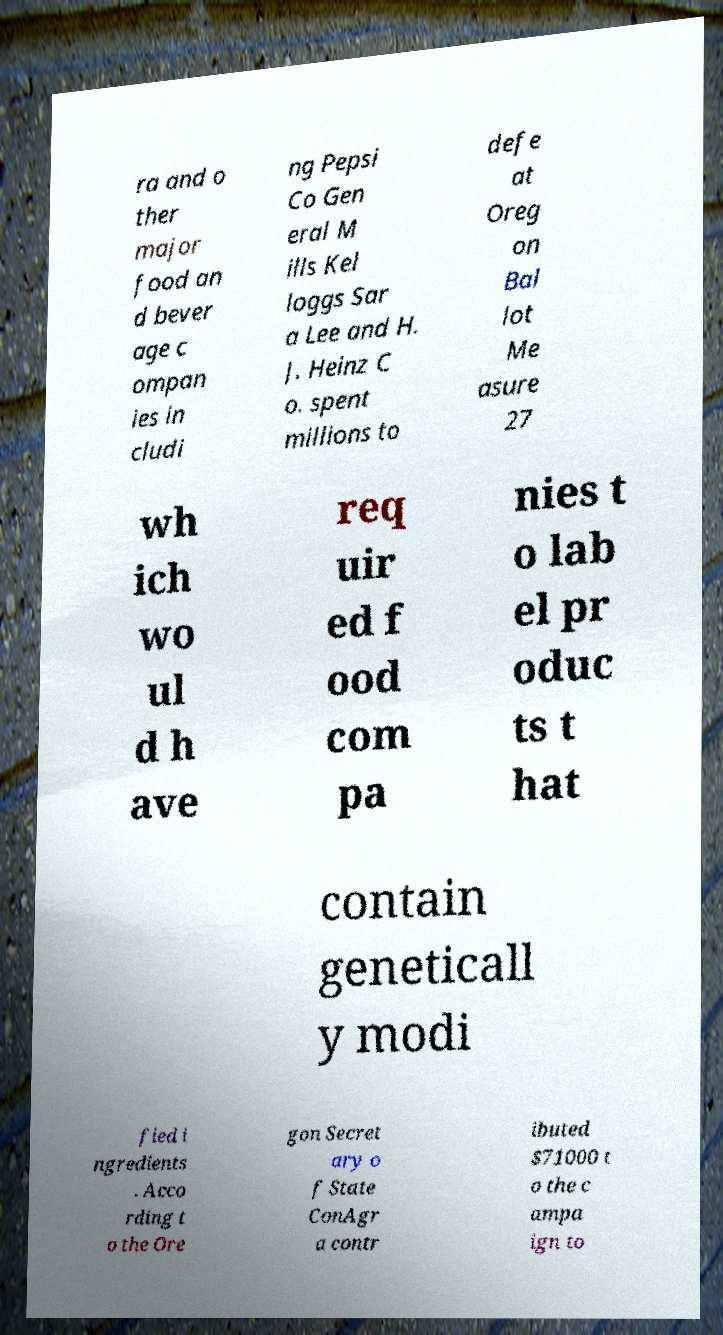Could you extract and type out the text from this image? ra and o ther major food an d bever age c ompan ies in cludi ng Pepsi Co Gen eral M ills Kel loggs Sar a Lee and H. J. Heinz C o. spent millions to defe at Oreg on Bal lot Me asure 27 wh ich wo ul d h ave req uir ed f ood com pa nies t o lab el pr oduc ts t hat contain geneticall y modi fied i ngredients . Acco rding t o the Ore gon Secret ary o f State ConAgr a contr ibuted $71000 t o the c ampa ign to 